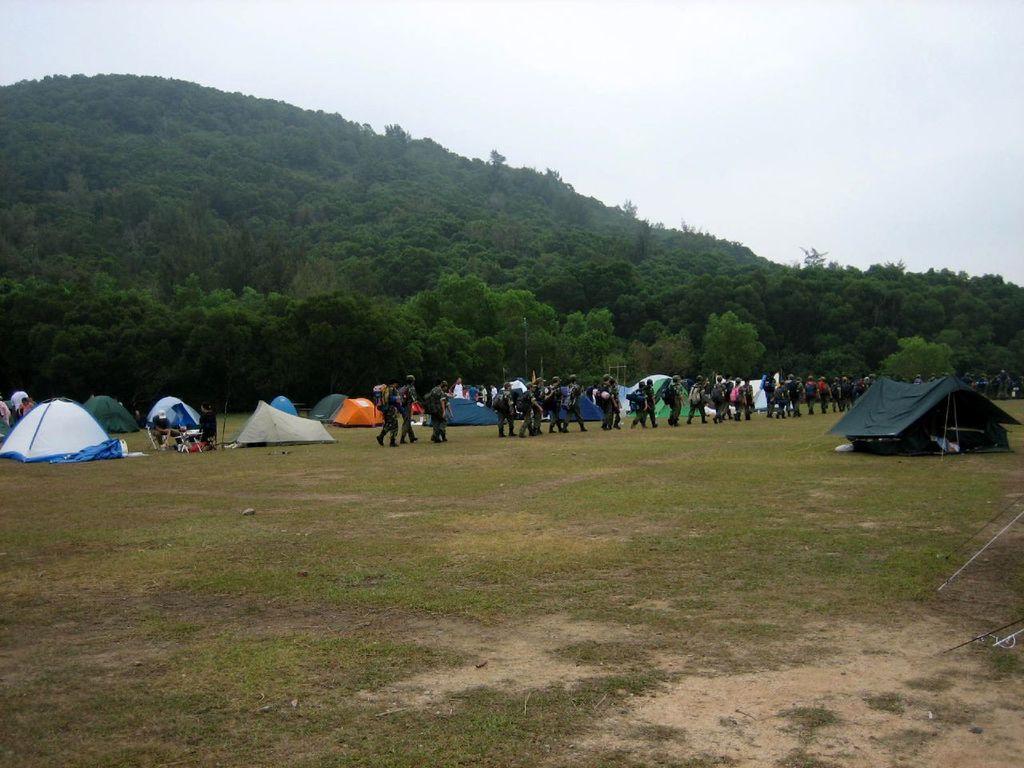In one or two sentences, can you explain what this image depicts? In this image I can see the group of people with the dresses and the bags. I can see the tents on the ground. In the background I can see many trees, mountain and the sky. 